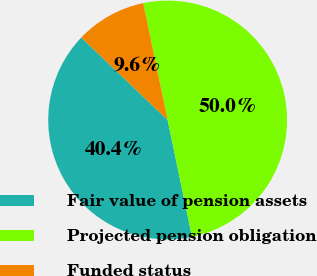Convert chart. <chart><loc_0><loc_0><loc_500><loc_500><pie_chart><fcel>Fair value of pension assets<fcel>Projected pension obligation<fcel>Funded status<nl><fcel>40.41%<fcel>50.0%<fcel>9.59%<nl></chart> 